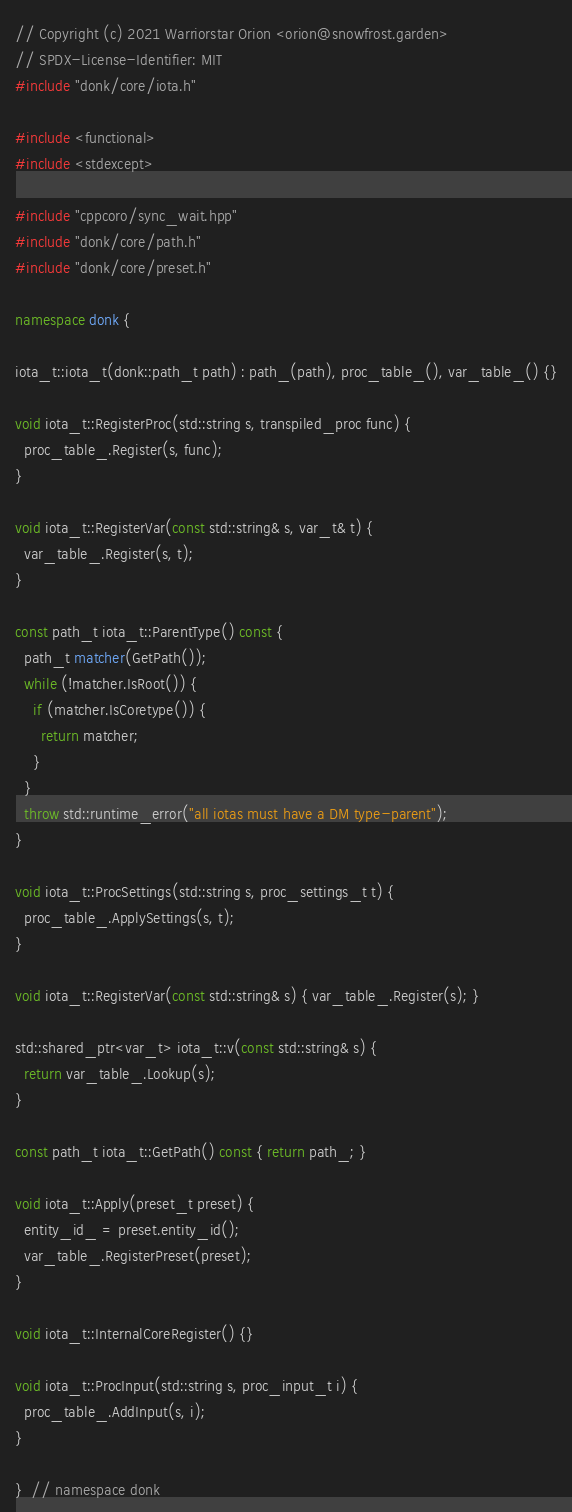<code> <loc_0><loc_0><loc_500><loc_500><_C++_>// Copyright (c) 2021 Warriorstar Orion <orion@snowfrost.garden>
// SPDX-License-Identifier: MIT
#include "donk/core/iota.h"

#include <functional>
#include <stdexcept>

#include "cppcoro/sync_wait.hpp"
#include "donk/core/path.h"
#include "donk/core/preset.h"

namespace donk {

iota_t::iota_t(donk::path_t path) : path_(path), proc_table_(), var_table_() {}

void iota_t::RegisterProc(std::string s, transpiled_proc func) {
  proc_table_.Register(s, func);
}

void iota_t::RegisterVar(const std::string& s, var_t& t) {
  var_table_.Register(s, t);
}

const path_t iota_t::ParentType() const {
  path_t matcher(GetPath());
  while (!matcher.IsRoot()) {
    if (matcher.IsCoretype()) {
      return matcher;
    }
  }
  throw std::runtime_error("all iotas must have a DM type-parent");
}

void iota_t::ProcSettings(std::string s, proc_settings_t t) {
  proc_table_.ApplySettings(s, t);
}

void iota_t::RegisterVar(const std::string& s) { var_table_.Register(s); }

std::shared_ptr<var_t> iota_t::v(const std::string& s) {
  return var_table_.Lookup(s);
}

const path_t iota_t::GetPath() const { return path_; }

void iota_t::Apply(preset_t preset) {
  entity_id_ = preset.entity_id();
  var_table_.RegisterPreset(preset);
}

void iota_t::InternalCoreRegister() {}

void iota_t::ProcInput(std::string s, proc_input_t i) {
  proc_table_.AddInput(s, i);
}

}  // namespace donk
</code> 